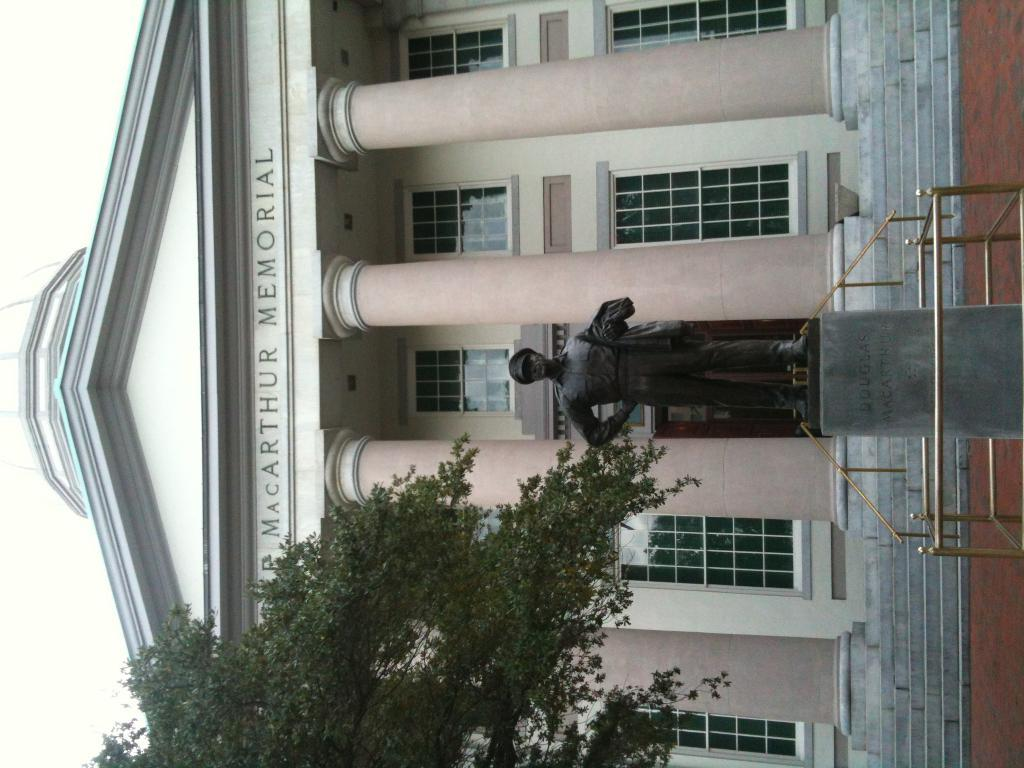What type of structure is present in the image? There is a building in the image. What can be seen on the wall of the building? There is text on the wall of the building. What other object is present in the image? There is a statue in the image. What type of vegetation is visible in the image? There is a tree in the image. What part of the natural environment is visible in the image? The sky is visible in the image. What type of beam is being used by the statue in the image? There is no beam present in the image, and the statue is not shown using any type of beam. 